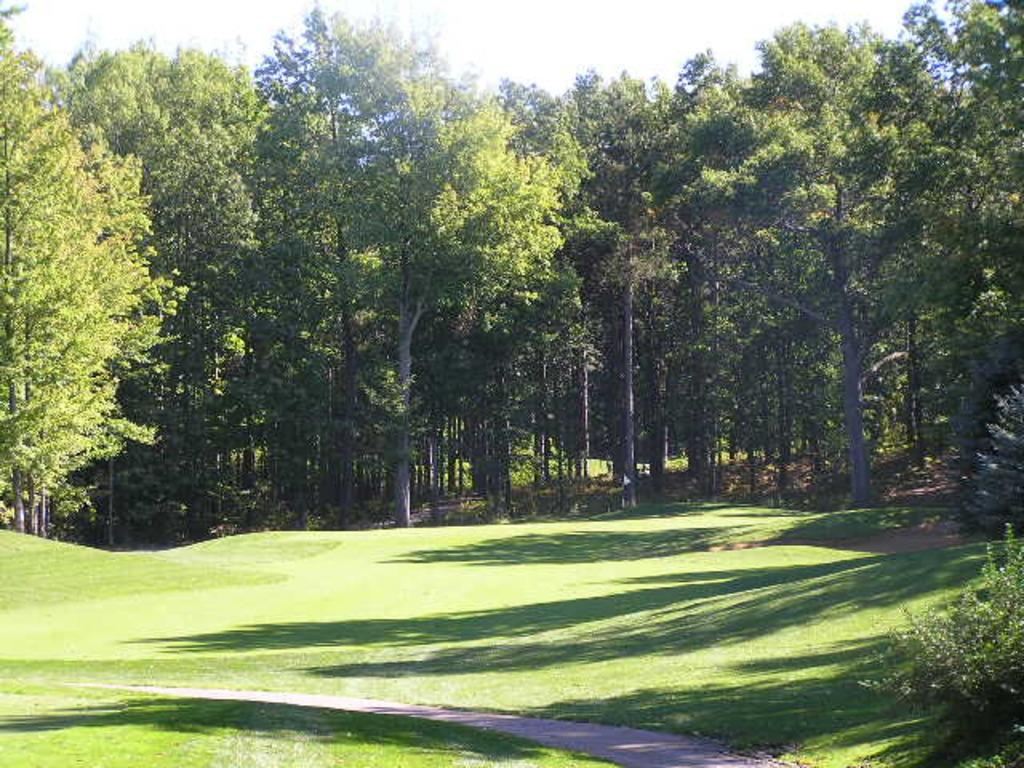What type of vegetation can be seen in the image? There are trees in the image. What is on the ground in the image? There is grass on the ground in the image. What is the condition of the sky in the image? The sky is cloudy in the image. Where is the shelf located in the image? There is no shelf present in the image. Can you see any worms crawling on the grass in the image? There are no worms visible in the image. 